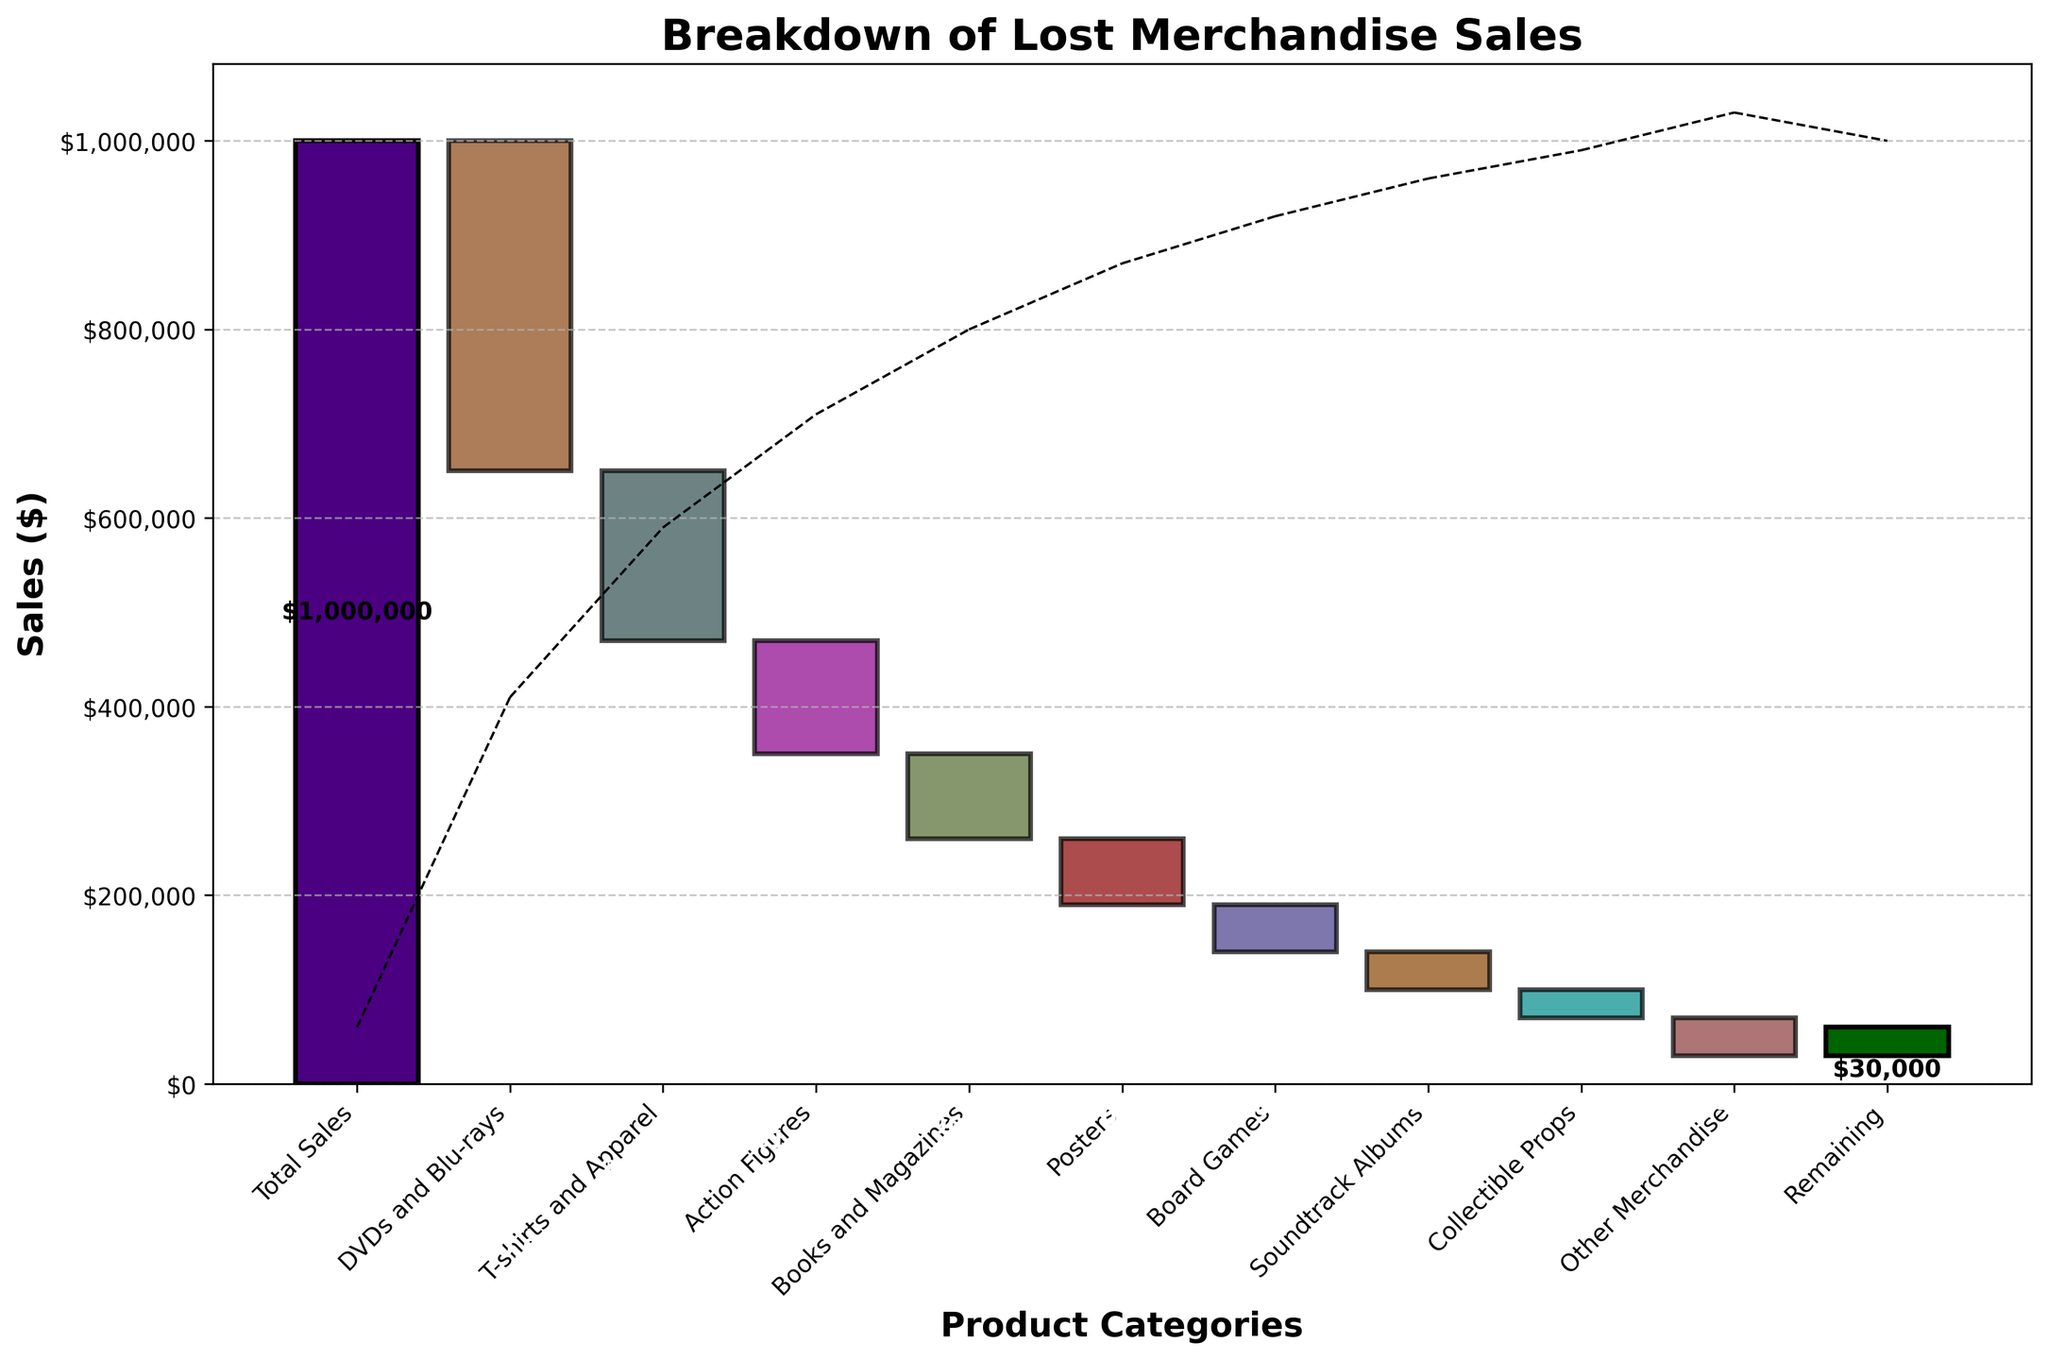What is the title of the chart? The title of the chart is displayed at the top of the figure, which provides insight into the overall topic of the data presented. By looking at the chart, we see the title is "Breakdown of Lost Merchandise Sales."
Answer: Breakdown of Lost Merchandise Sales How many product categories are listed in the chart, including the total and remaining sales? To determine the number of product categories, count the number of bars representing each category. There are 11 bars, including Total Sales and Remaining.
Answer: 11 Which product category had the highest negative impact on sales? The product category with the highest negative impact can be identified by looking for the longest bar going downward. DVDs and Blu-rays have the longest downward bar.
Answer: DVDs and Blu-rays What is the total negative sales amount from all the categories combined? To find the total negative sales, sum up all the negative values: -350,000 + -180,000 + -120,000 + -90,000 + -70,000 + -50,000 + -40,000 + -30,000 + -40,000 = -970,000.
Answer: -970,000 How do the sales of T-shirts and Apparel compare to Action Figures? This can be assessed by comparing the lengths of the bars for these two categories. T-shirts and Apparel have a loss of -180,000, while Action Figures have a loss of -120,000. T-shirts and Apparel have a greater negative impact on sales.
Answer: T-shirts and Apparel had a larger negative impact What is the value of the remaining sales? Look at the value of the last bar labeled "Remaining." It indicates the final amount after all product categories have been accounted for. The value is $30,000.
Answer: $30,000 If DVDs and Blu-rays sales hadn't been considered, what would the total sales be? To answer this, add back the DVD and Blu-ray value to the final remaining value: $30,000 + $350,000 = $380,000.
Answer: $380,000 What is the difference in sales impact between Books and Magazines and Posters? To find this, subtract the sales impact of Posters from Books and Magazines: $(-70,000) - $(-90,000) = $20,000.
Answer: $20,000 Which product category had the smallest negative impact on sales? Identify the shortest downward bar among the product categories. Collectible Props had the smallest negative impact with -$30,000.
Answer: Collectible Props 